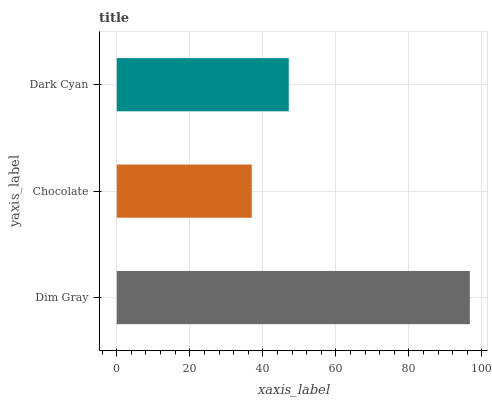Is Chocolate the minimum?
Answer yes or no. Yes. Is Dim Gray the maximum?
Answer yes or no. Yes. Is Dark Cyan the minimum?
Answer yes or no. No. Is Dark Cyan the maximum?
Answer yes or no. No. Is Dark Cyan greater than Chocolate?
Answer yes or no. Yes. Is Chocolate less than Dark Cyan?
Answer yes or no. Yes. Is Chocolate greater than Dark Cyan?
Answer yes or no. No. Is Dark Cyan less than Chocolate?
Answer yes or no. No. Is Dark Cyan the high median?
Answer yes or no. Yes. Is Dark Cyan the low median?
Answer yes or no. Yes. Is Dim Gray the high median?
Answer yes or no. No. Is Dim Gray the low median?
Answer yes or no. No. 